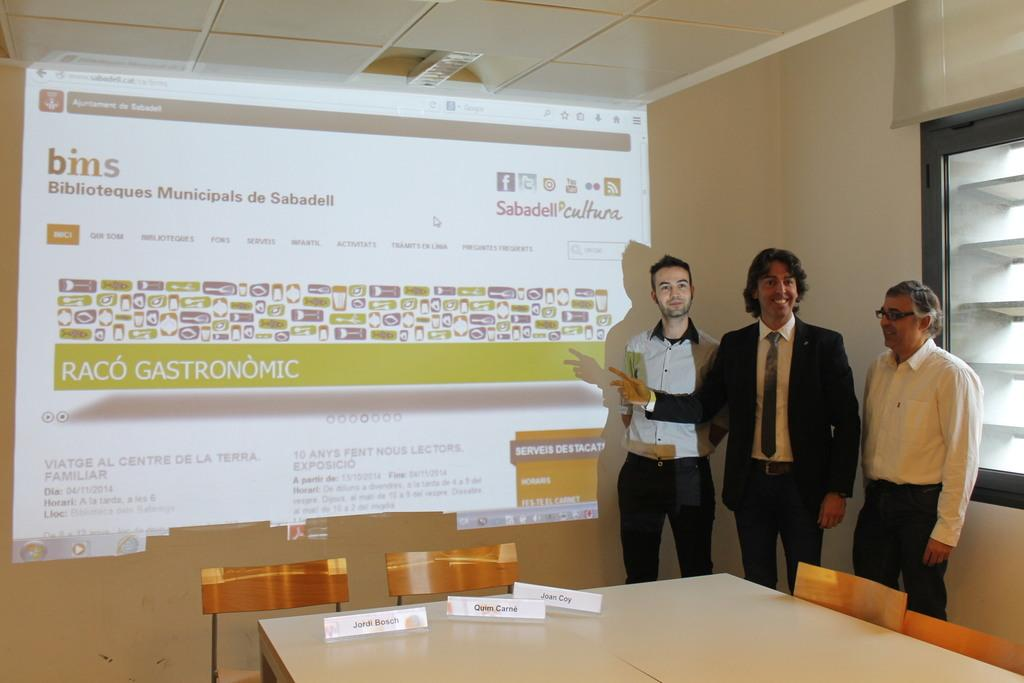How many people are in the image? There are three persons standing in the image. What is the surface they are standing on? The persons are standing on the floor. What furniture can be seen in the image? There is a table and chairs in the image. What is visible in the background of the image? There is a screen and a wall in the background of the image. What is the average income of the persons in the image? There is no information about the income of the persons in the image, so it cannot be determined. 